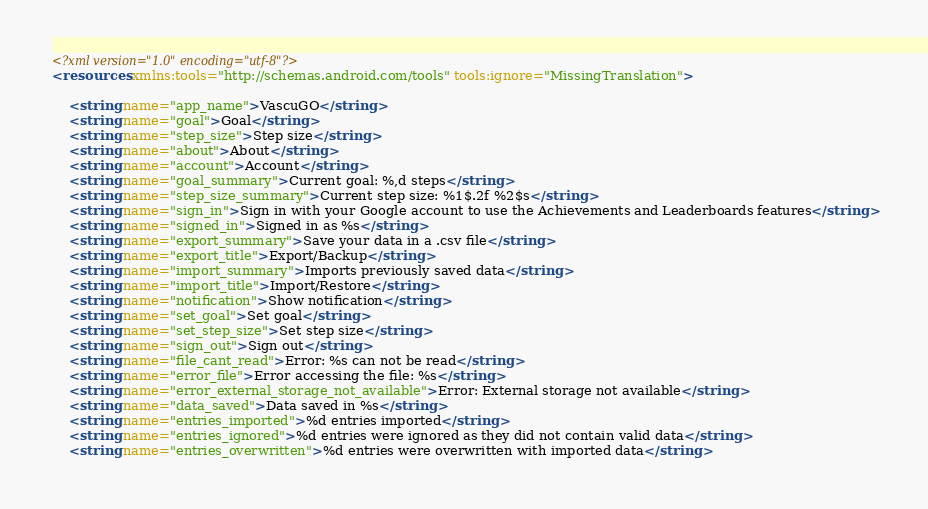Convert code to text. <code><loc_0><loc_0><loc_500><loc_500><_XML_><?xml version="1.0" encoding="utf-8"?>
<resources xmlns:tools="http://schemas.android.com/tools" tools:ignore="MissingTranslation">

    <string name="app_name">VascuGO</string>
    <string name="goal">Goal</string>
    <string name="step_size">Step size</string>
    <string name="about">About</string>
    <string name="account">Account</string>
    <string name="goal_summary">Current goal: %,d steps</string>
    <string name="step_size_summary">Current step size: %1$.2f %2$s</string>
    <string name="sign_in">Sign in with your Google account to use the Achievements and Leaderboards features</string>
    <string name="signed_in">Signed in as %s</string>
    <string name="export_summary">Save your data in a .csv file</string>
    <string name="export_title">Export/Backup</string>
    <string name="import_summary">Imports previously saved data</string>
    <string name="import_title">Import/Restore</string>
    <string name="notification">Show notification</string>
    <string name="set_goal">Set goal</string>
    <string name="set_step_size">Set step size</string>
    <string name="sign_out">Sign out</string>
    <string name="file_cant_read">Error: %s can not be read</string>
    <string name="error_file">Error accessing the file: %s</string>
    <string name="error_external_storage_not_available">Error: External storage not available</string>
    <string name="data_saved">Data saved in %s</string>
    <string name="entries_imported">%d entries imported</string>
    <string name="entries_ignored">%d entries were ignored as they did not contain valid data</string>
    <string name="entries_overwritten">%d entries were overwritten with imported data</string></code> 